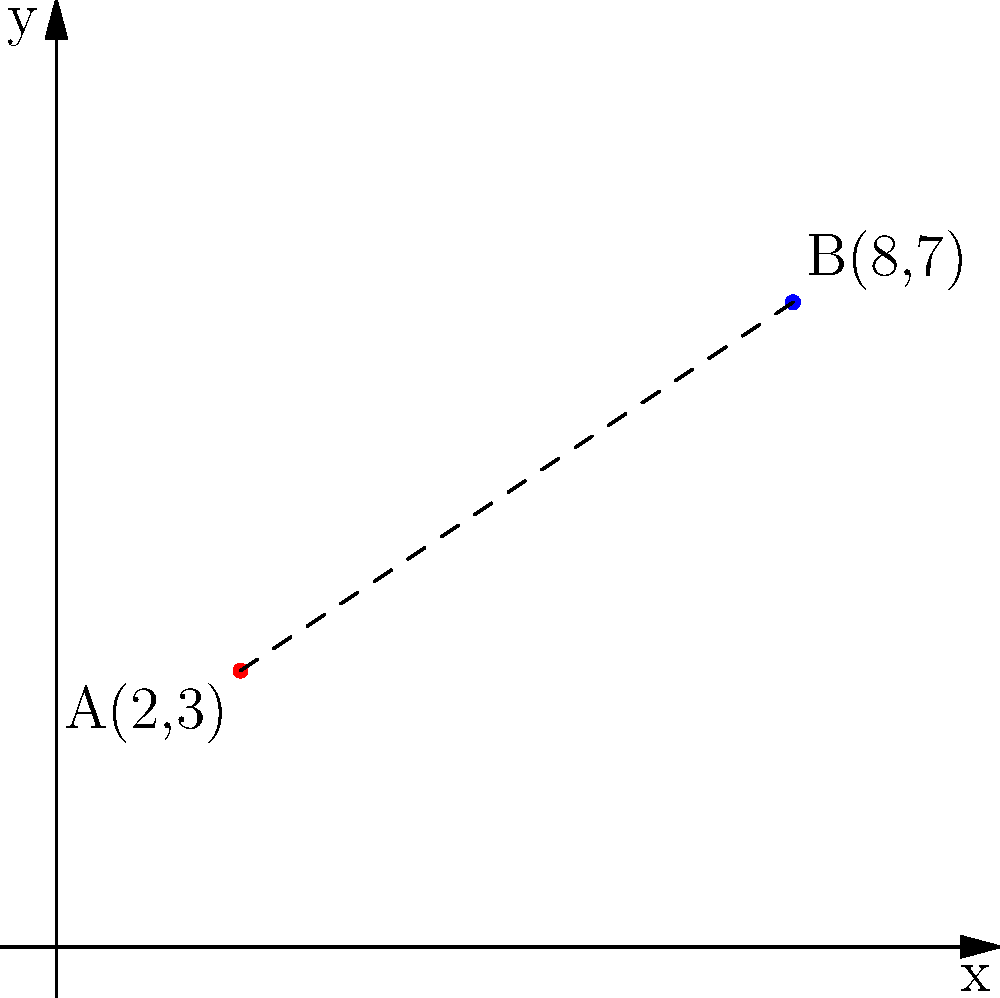In an image processing task, you need to calculate the distance between two pixels on a 2D plane. Given pixel A with coordinates (2, 3) and pixel B with coordinates (8, 7), determine the Euclidean distance between these two points. Round your answer to two decimal places. To find the Euclidean distance between two points in a 2D plane, we can use the distance formula derived from the Pythagorean theorem:

$$ d = \sqrt{(x_2 - x_1)^2 + (y_2 - y_1)^2} $$

Where $(x_1, y_1)$ are the coordinates of the first point and $(x_2, y_2)$ are the coordinates of the second point.

Step 1: Identify the coordinates
Point A: $(x_1, y_1) = (2, 3)$
Point B: $(x_2, y_2) = (8, 7)$

Step 2: Calculate the differences
$x_2 - x_1 = 8 - 2 = 6$
$y_2 - y_1 = 7 - 3 = 4$

Step 3: Square the differences
$(x_2 - x_1)^2 = 6^2 = 36$
$(y_2 - y_1)^2 = 4^2 = 16$

Step 4: Sum the squared differences
$36 + 16 = 52$

Step 5: Calculate the square root
$\sqrt{52} \approx 7.2111$

Step 6: Round to two decimal places
$7.21$

Therefore, the Euclidean distance between pixels A and B is approximately 7.21 units.
Answer: 7.21 